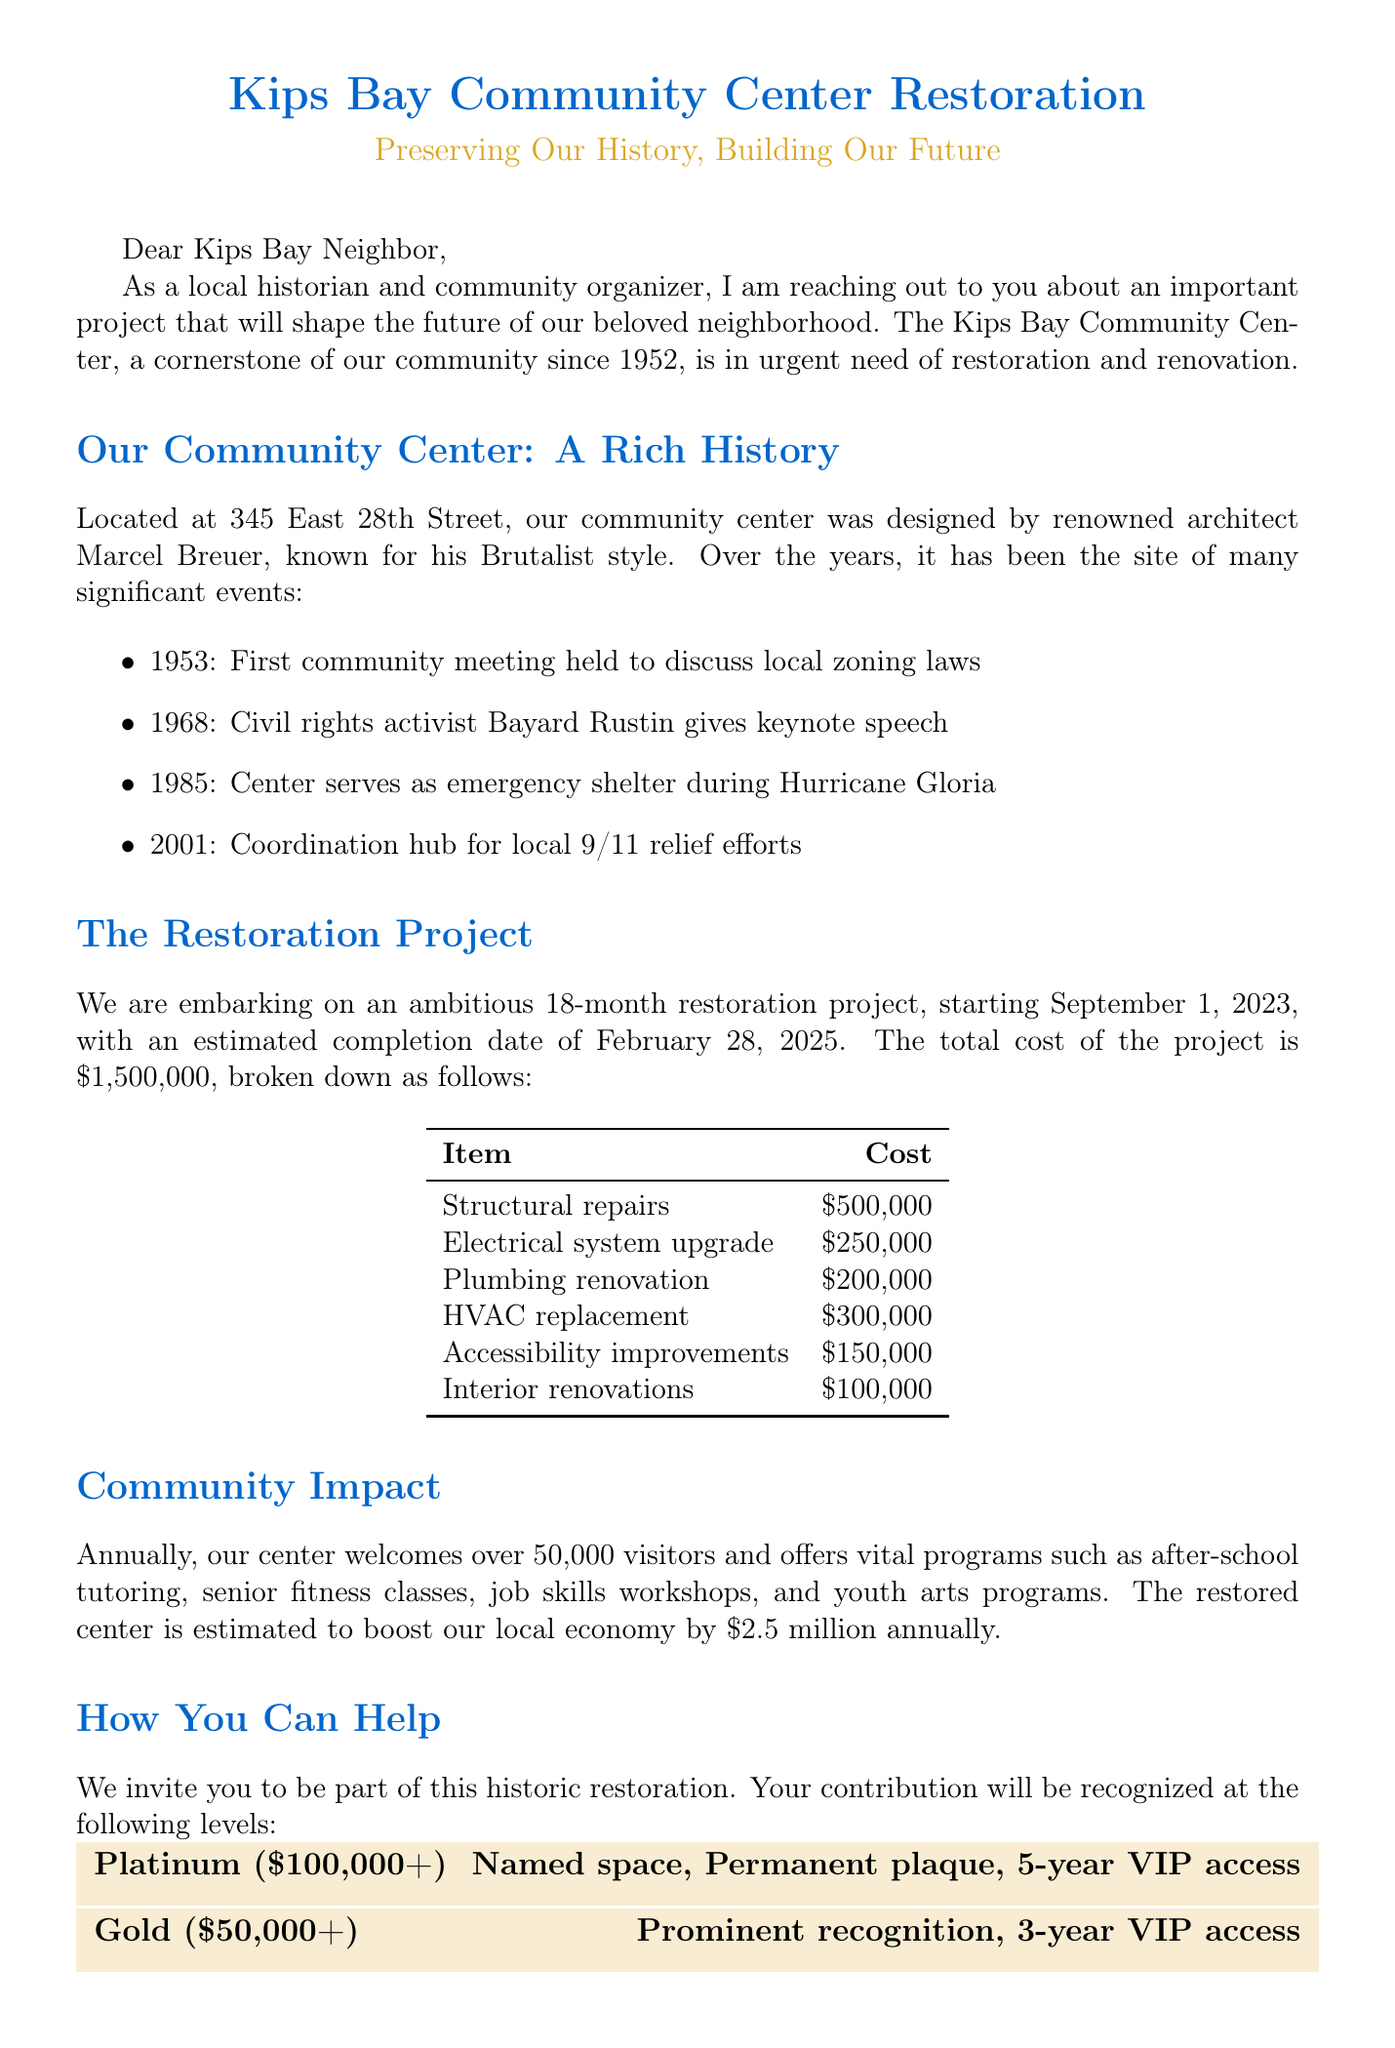What is the total cost of the restoration project? The total cost is explicitly mentioned in the document as the total expense for the project.
Answer: $1,500,000 Who is the project manager for the restoration project? The document states the Kips Bay Restoration Committee is responsible for managing the project, providing the name of the committee rather than an individual name.
Answer: Kips Bay Restoration Committee When will the restoration project start? The start date for the restoration project is clearly outlined in the document.
Answer: September 1, 2023 What architectural style is the Kips Bay Community Center known for? The document specifies the style of the community center's design, attributed to its architect.
Answer: Brutalist How long is the restoration project expected to take? This duration is stated as part of the project schedule outlined in the document.
Answer: 18 months What is one of the annual programs offered at the center? The document lists several programs available at the center, with this being one of them.
Answer: After-school tutoring What recognition do Platinum donors receive? The document provides details about the perks associated with donation levels, specifically for Platinum donors.
Answer: Named space in the center What is the historical significance of the Kips Bay Community Center? The document mentions its notable architect and design style, which contributes to its importance in the community.
Answer: Designed by renowned architect Marcel Breuer Who is the chair of the fundraising committee? The document lists the leadership of the fundraising committee under specific titles, including the chair position.
Answer: Maria Rodriguez 